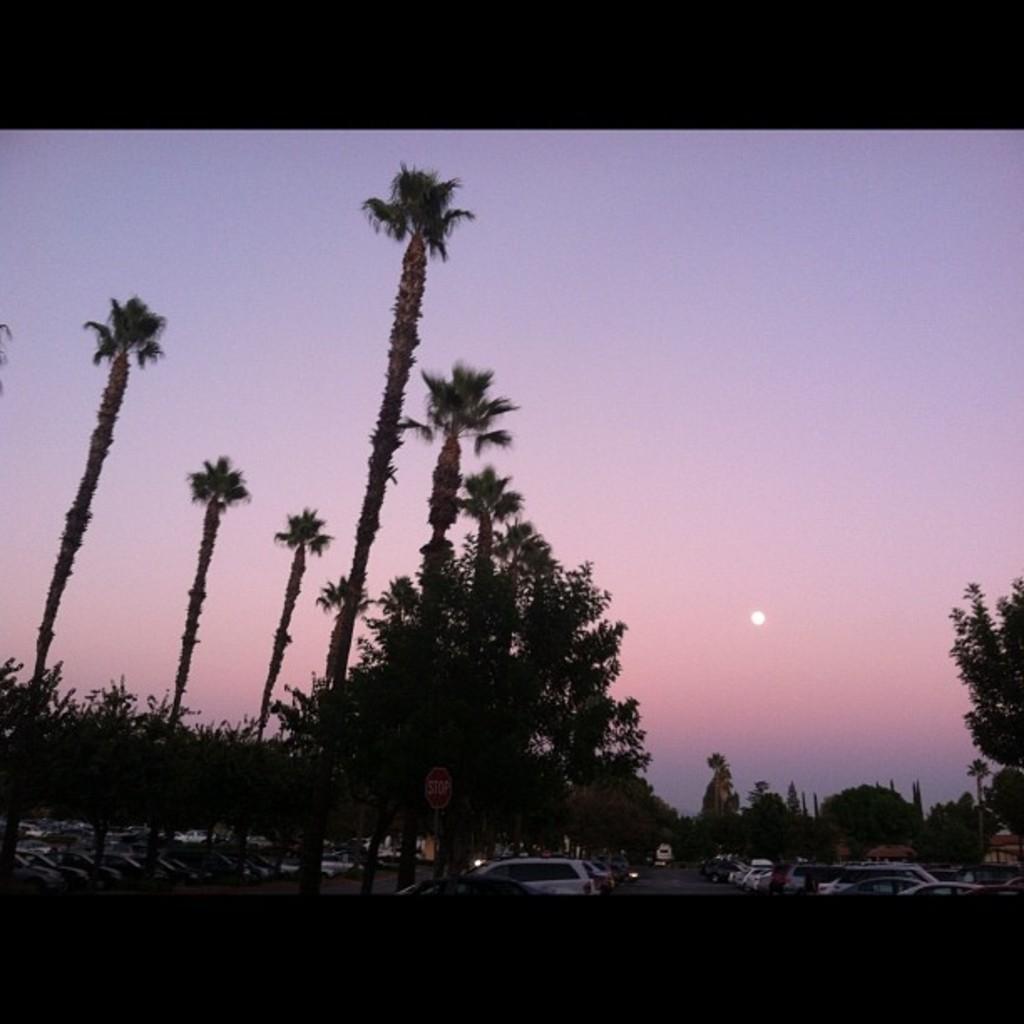How would you summarize this image in a sentence or two? In this image, there is an outside view. In the foreground, there are some trees and vehicles. In the background, there is a sky. 